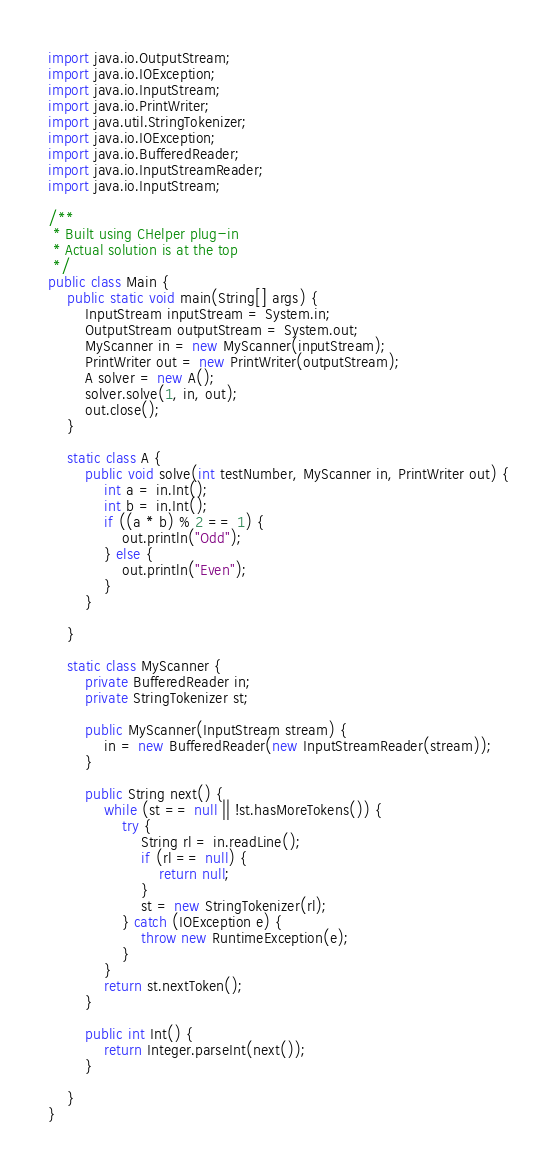<code> <loc_0><loc_0><loc_500><loc_500><_Java_>import java.io.OutputStream;
import java.io.IOException;
import java.io.InputStream;
import java.io.PrintWriter;
import java.util.StringTokenizer;
import java.io.IOException;
import java.io.BufferedReader;
import java.io.InputStreamReader;
import java.io.InputStream;

/**
 * Built using CHelper plug-in
 * Actual solution is at the top
 */
public class Main {
    public static void main(String[] args) {
        InputStream inputStream = System.in;
        OutputStream outputStream = System.out;
        MyScanner in = new MyScanner(inputStream);
        PrintWriter out = new PrintWriter(outputStream);
        A solver = new A();
        solver.solve(1, in, out);
        out.close();
    }

    static class A {
        public void solve(int testNumber, MyScanner in, PrintWriter out) {
            int a = in.Int();
            int b = in.Int();
            if ((a * b) % 2 == 1) {
                out.println("Odd");
            } else {
                out.println("Even");
            }
        }

    }

    static class MyScanner {
        private BufferedReader in;
        private StringTokenizer st;

        public MyScanner(InputStream stream) {
            in = new BufferedReader(new InputStreamReader(stream));
        }

        public String next() {
            while (st == null || !st.hasMoreTokens()) {
                try {
                    String rl = in.readLine();
                    if (rl == null) {
                        return null;
                    }
                    st = new StringTokenizer(rl);
                } catch (IOException e) {
                    throw new RuntimeException(e);
                }
            }
            return st.nextToken();
        }

        public int Int() {
            return Integer.parseInt(next());
        }

    }
}

</code> 